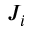<formula> <loc_0><loc_0><loc_500><loc_500>J _ { i }</formula> 